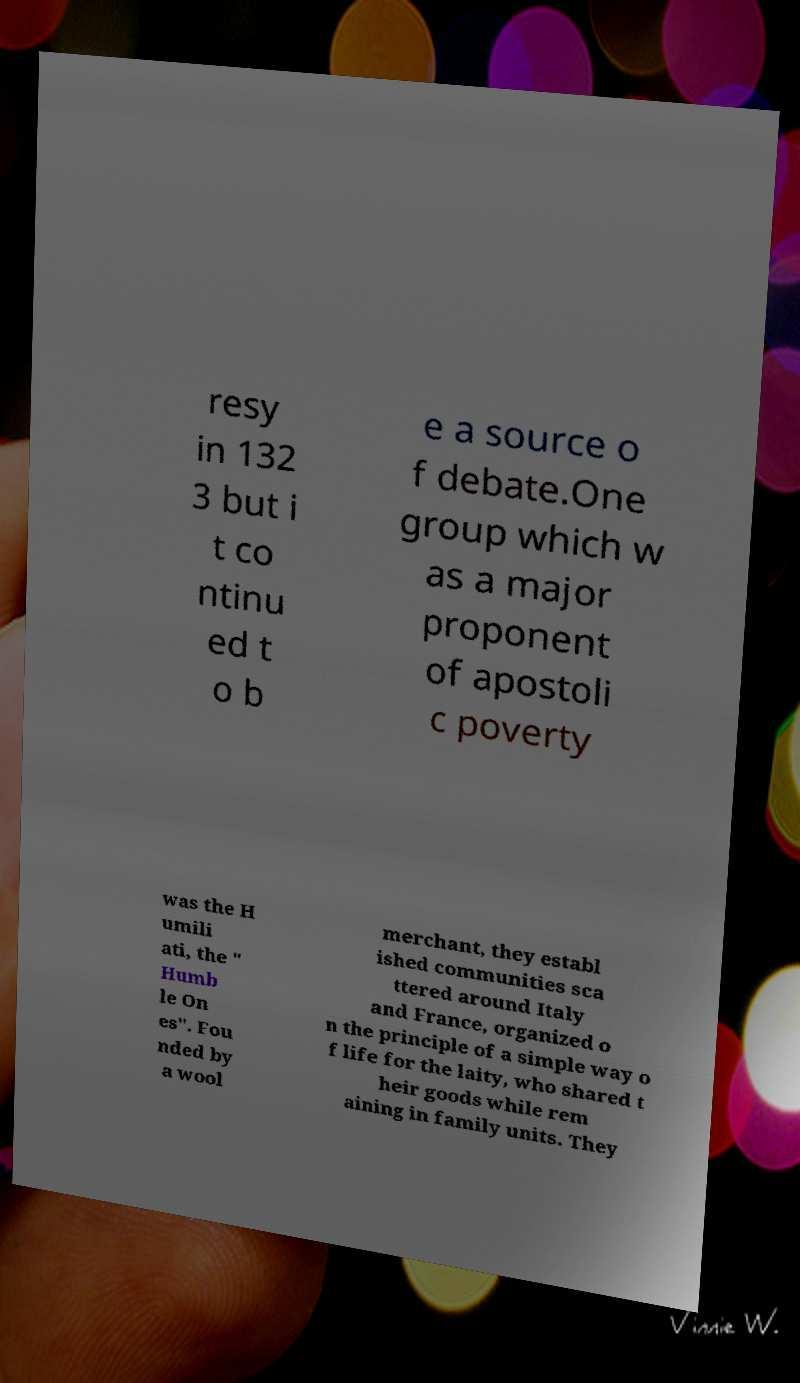Please identify and transcribe the text found in this image. resy in 132 3 but i t co ntinu ed t o b e a source o f debate.One group which w as a major proponent of apostoli c poverty was the H umili ati, the " Humb le On es". Fou nded by a wool merchant, they establ ished communities sca ttered around Italy and France, organized o n the principle of a simple way o f life for the laity, who shared t heir goods while rem aining in family units. They 